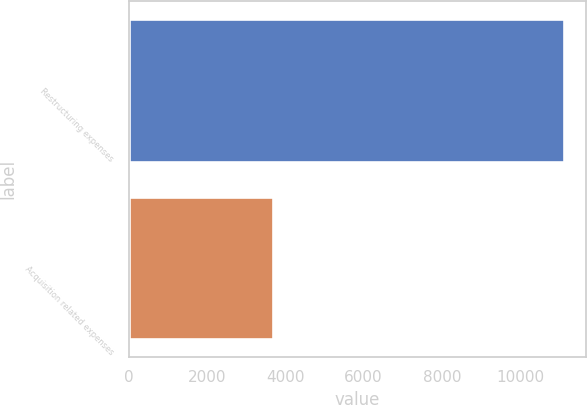<chart> <loc_0><loc_0><loc_500><loc_500><bar_chart><fcel>Restructuring expenses<fcel>Acquisition related expenses<nl><fcel>11123<fcel>3683<nl></chart> 